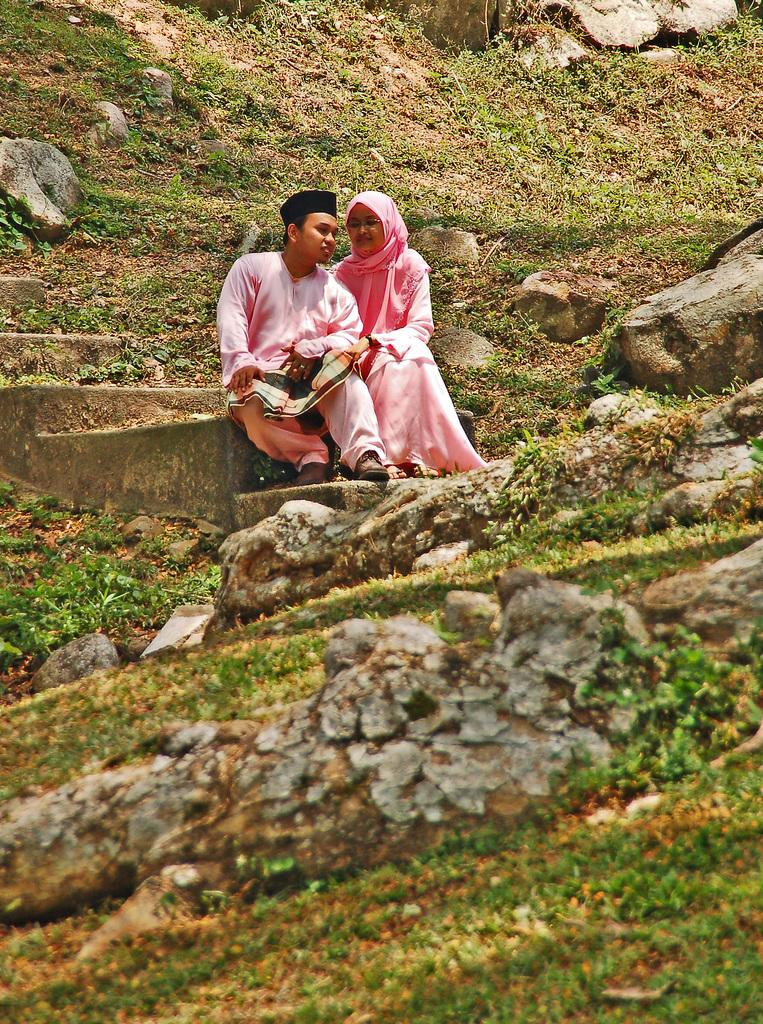How many people are in the image? There are two people in the image, a man and a woman. What are the man and woman wearing? Both the man and woman are wearing pink dresses. Where are the man and woman sitting? They are sitting on stairs. What type of natural environment is visible in the image? There are stones and grass visible in the image. What type of cap is the man wearing in the image? There is no cap visible in the image; the man is wearing a pink dress. What effect does the hall have on the people in the image? There is no hall present in the image; the man and woman are sitting on stairs outdoors. 